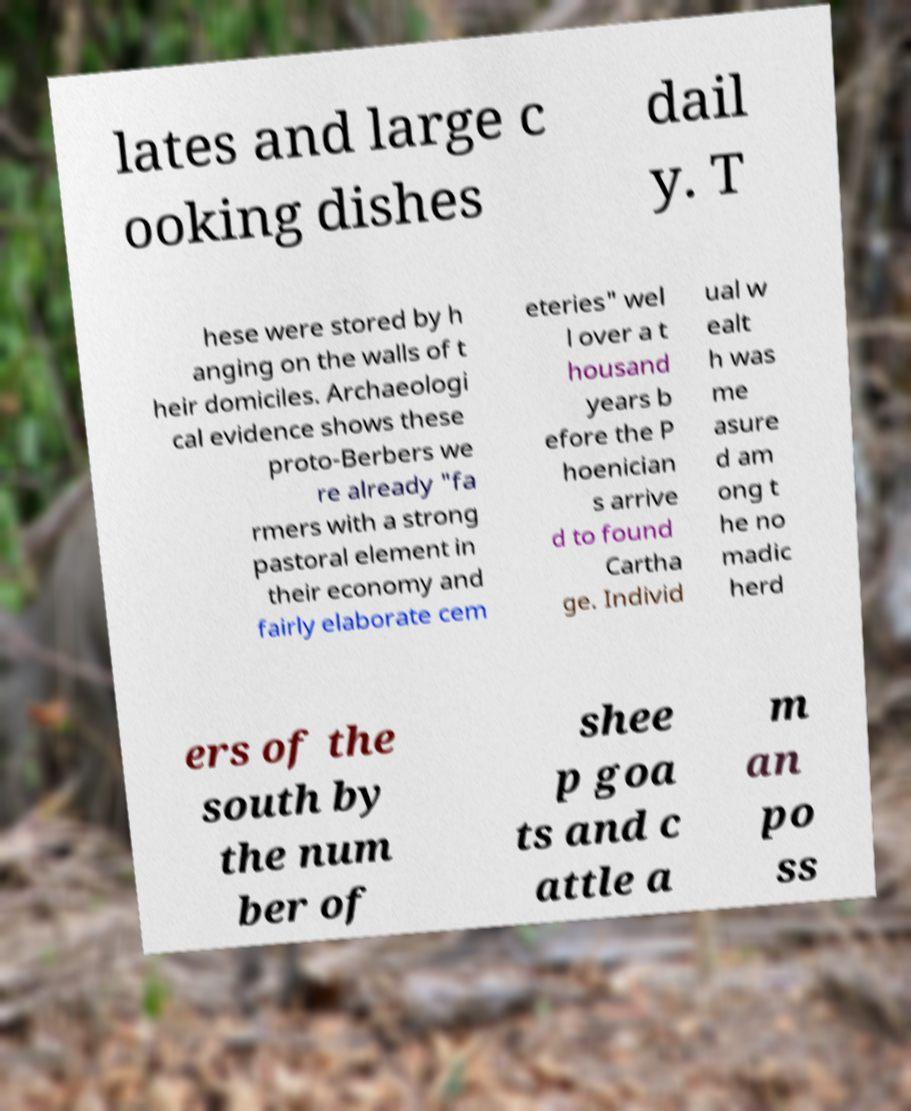For documentation purposes, I need the text within this image transcribed. Could you provide that? lates and large c ooking dishes dail y. T hese were stored by h anging on the walls of t heir domiciles. Archaeologi cal evidence shows these proto-Berbers we re already "fa rmers with a strong pastoral element in their economy and fairly elaborate cem eteries" wel l over a t housand years b efore the P hoenician s arrive d to found Cartha ge. Individ ual w ealt h was me asure d am ong t he no madic herd ers of the south by the num ber of shee p goa ts and c attle a m an po ss 